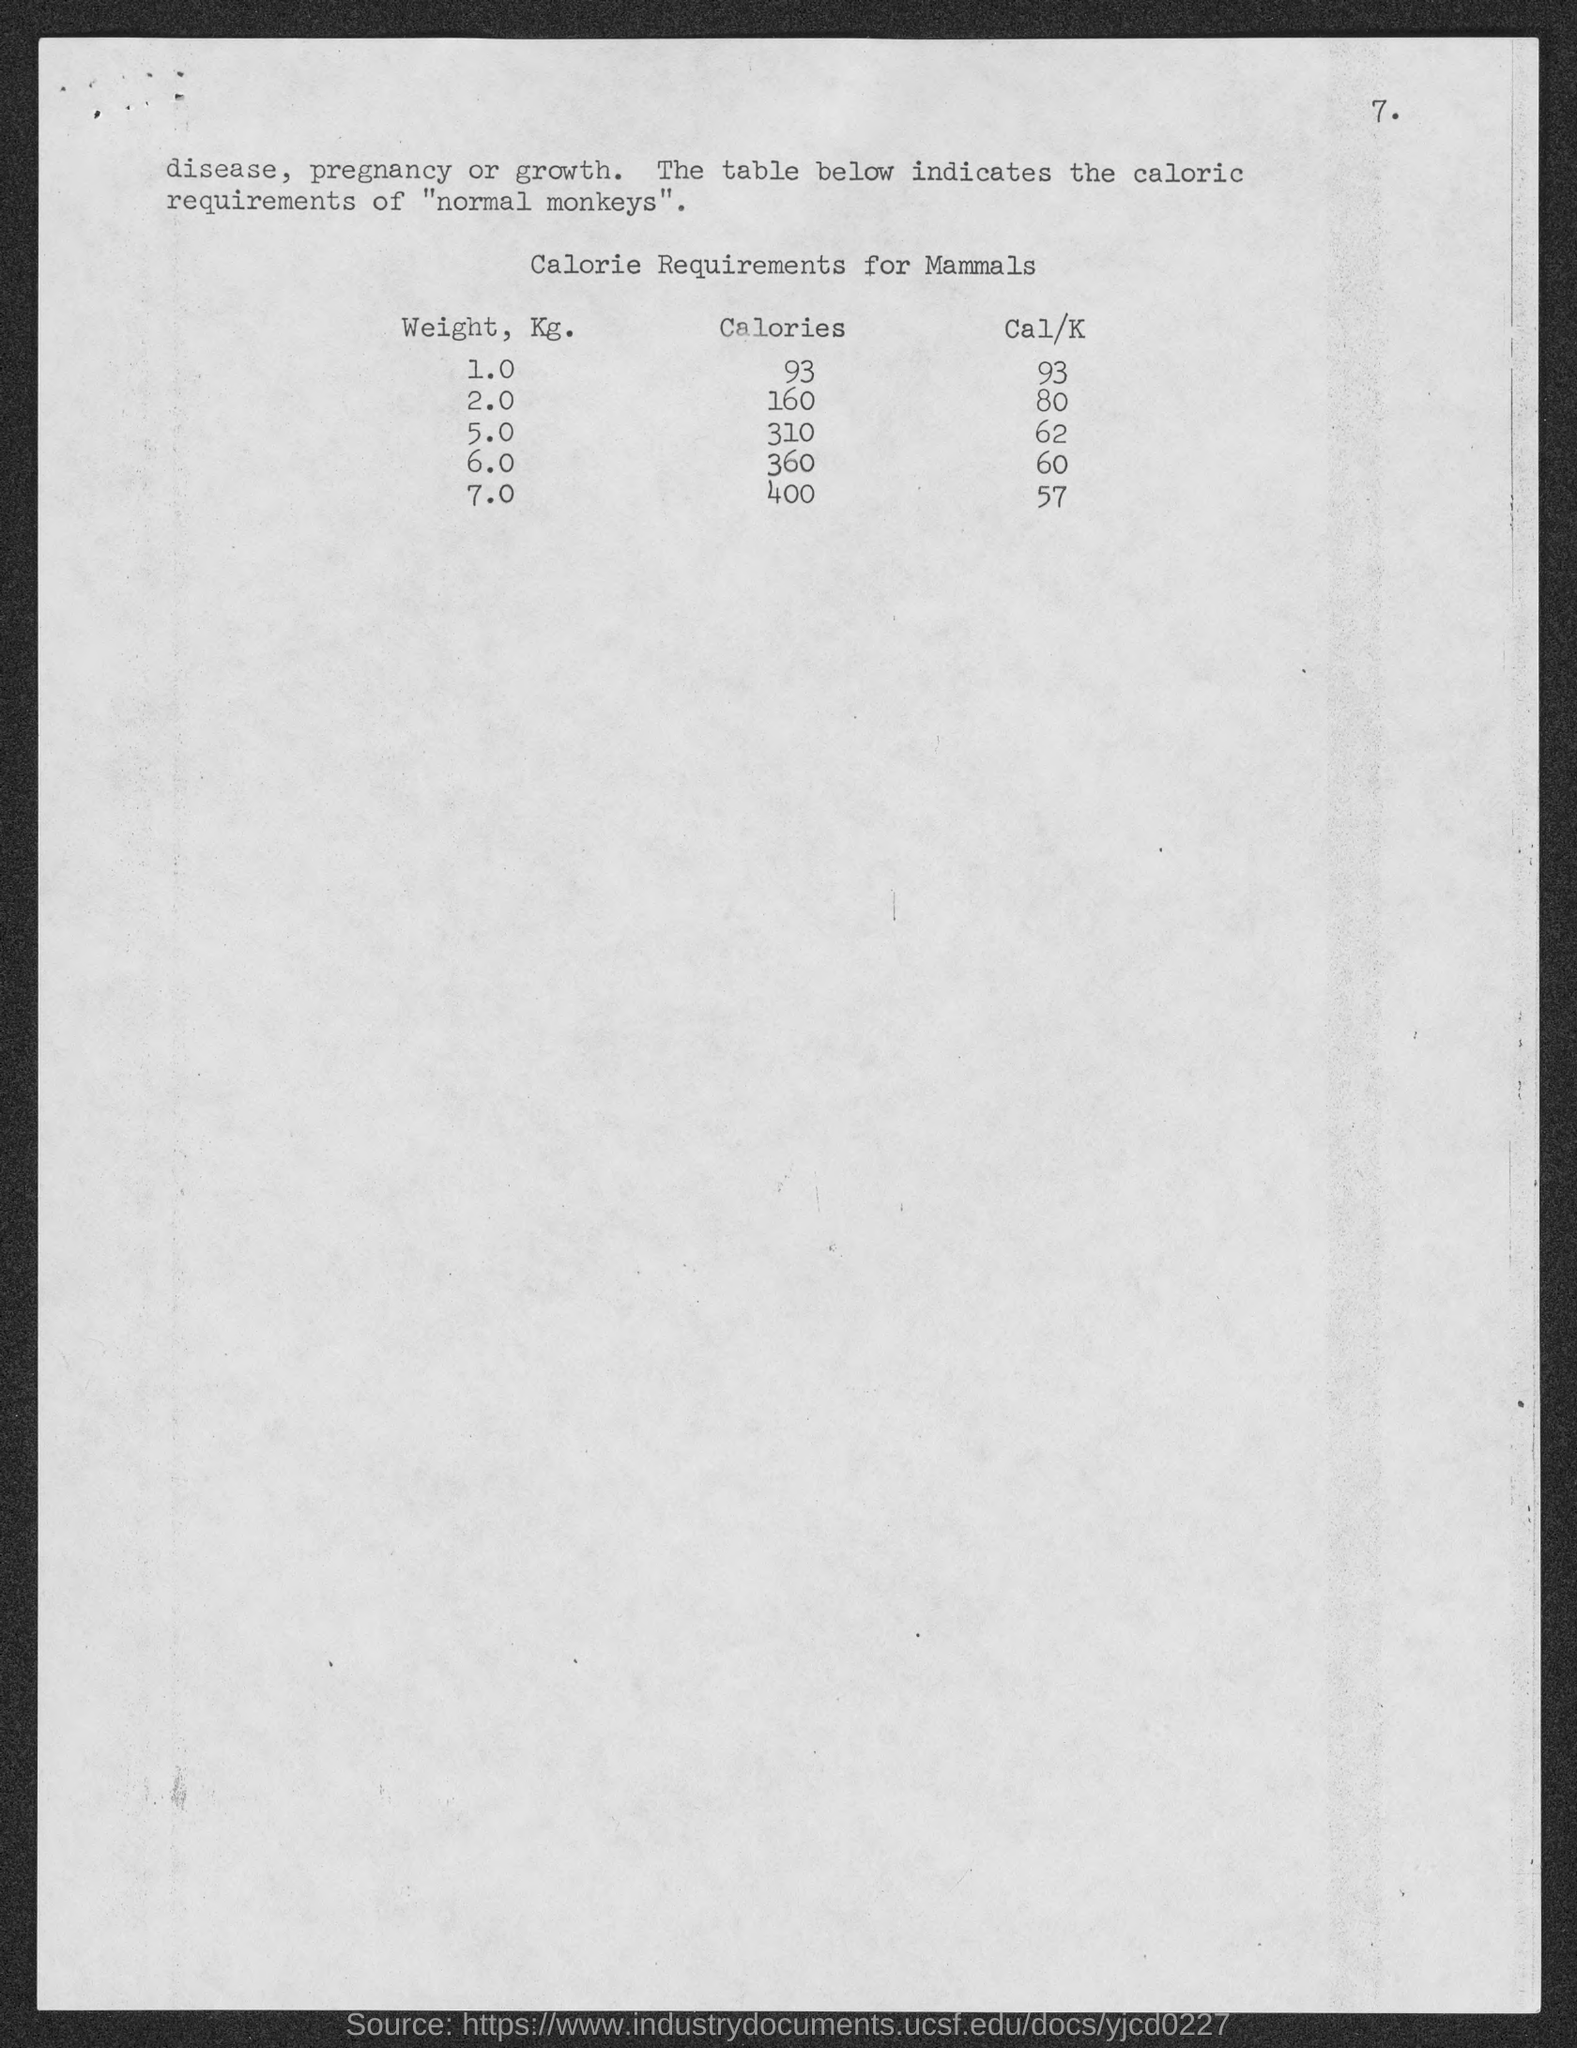What is the table heading ?
Your answer should be very brief. Calorie Requirements for Mammals. How much calories are required for 1 kg  mammals?
Your answer should be very brief. 93. How much " Cal/K"  for 2 kg Mammals ?
Ensure brevity in your answer.  80. How much calories are required for 2 kg  mammals?
Your answer should be very brief. 160. What is the highest weight of mammals in Kg shown in the table?
Your answer should be compact. 7.0. 